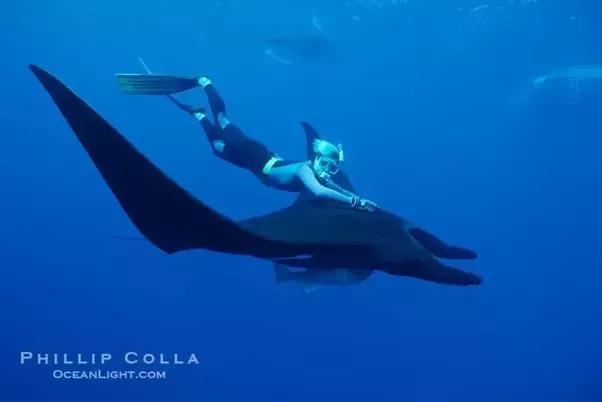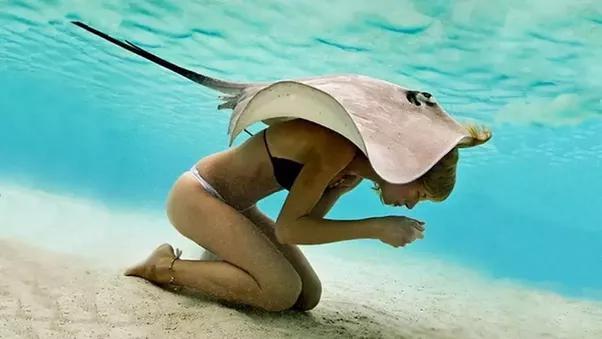The first image is the image on the left, the second image is the image on the right. Evaluate the accuracy of this statement regarding the images: "The right image shows the complete underbelly of a manta ray.". Is it true? Answer yes or no. No. 